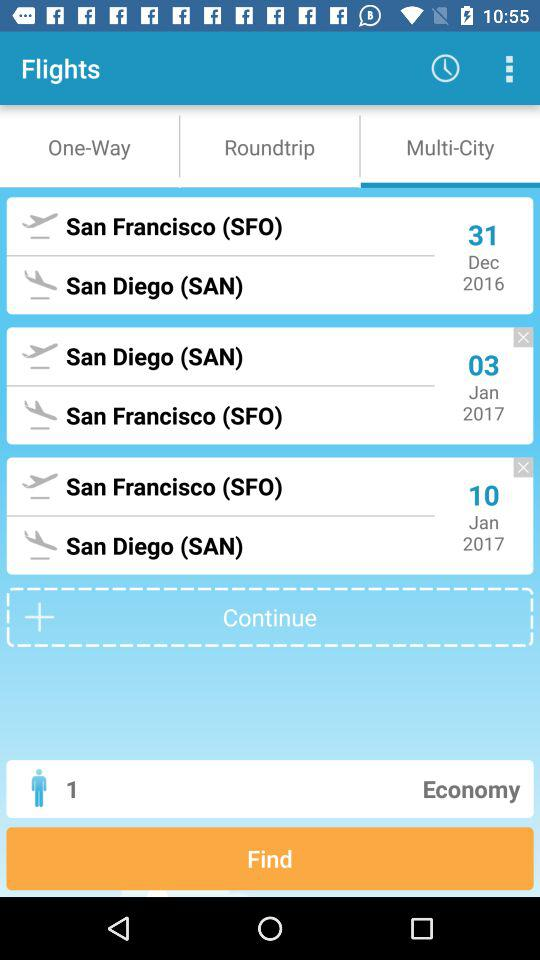What is the departure location for the 10th of January, 2017? The departure location for the 10th of January, 2017 is San Francisco. 